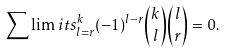<formula> <loc_0><loc_0><loc_500><loc_500>\sum \lim i t s _ { l = r } ^ { k } ( - 1 ) ^ { l - r } \binom { k } { l } \binom { l } { r } = 0 .</formula> 